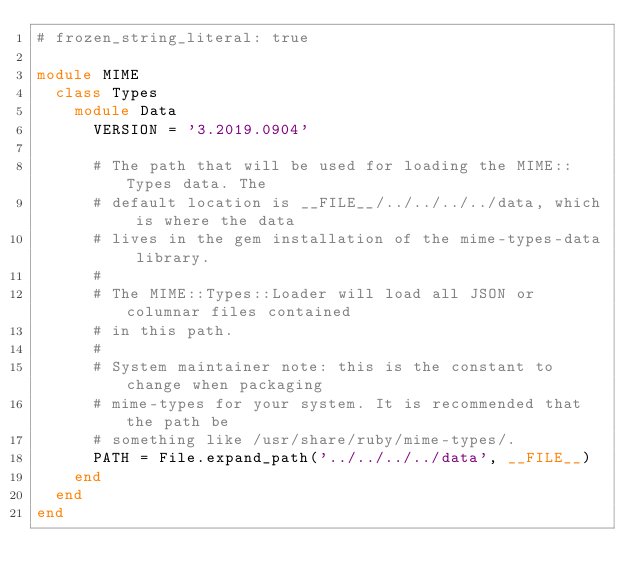<code> <loc_0><loc_0><loc_500><loc_500><_Ruby_># frozen_string_literal: true

module MIME
  class Types
    module Data
      VERSION = '3.2019.0904'

      # The path that will be used for loading the MIME::Types data. The
      # default location is __FILE__/../../../../data, which is where the data
      # lives in the gem installation of the mime-types-data library.
      #
      # The MIME::Types::Loader will load all JSON or columnar files contained
      # in this path.
      #
      # System maintainer note: this is the constant to change when packaging
      # mime-types for your system. It is recommended that the path be
      # something like /usr/share/ruby/mime-types/.
      PATH = File.expand_path('../../../../data', __FILE__)
    end
  end
end
</code> 